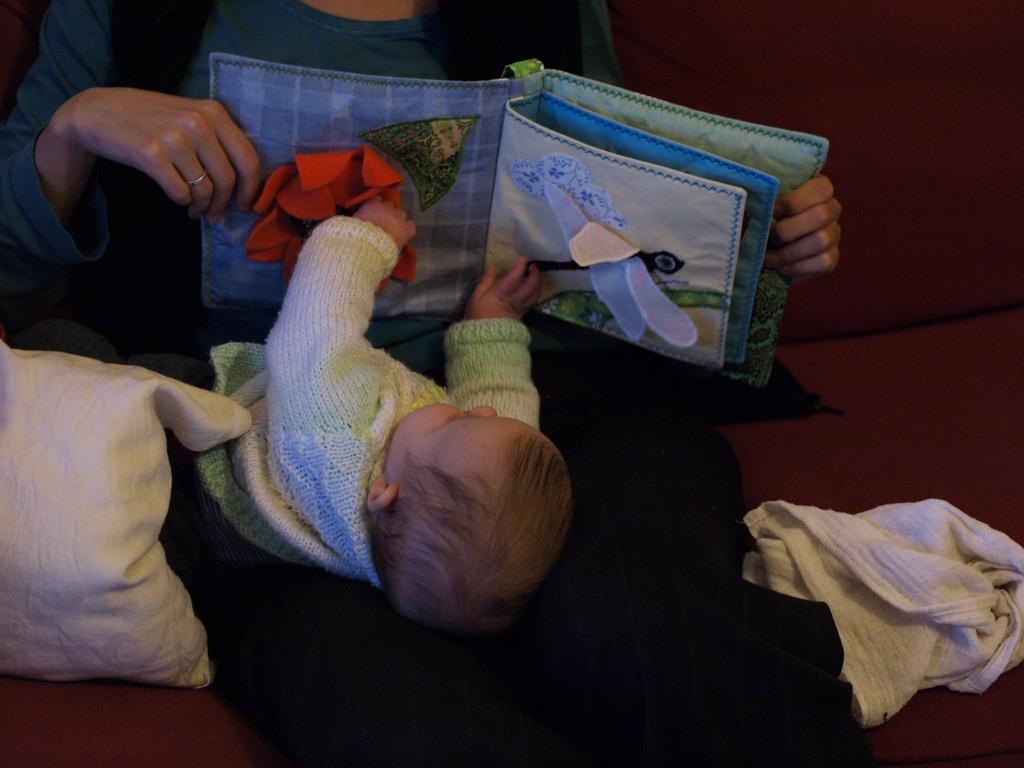Describe this image in one or two sentences. Here we can see a person holding a toy and a kid. This is cloth and there is a pillow. 